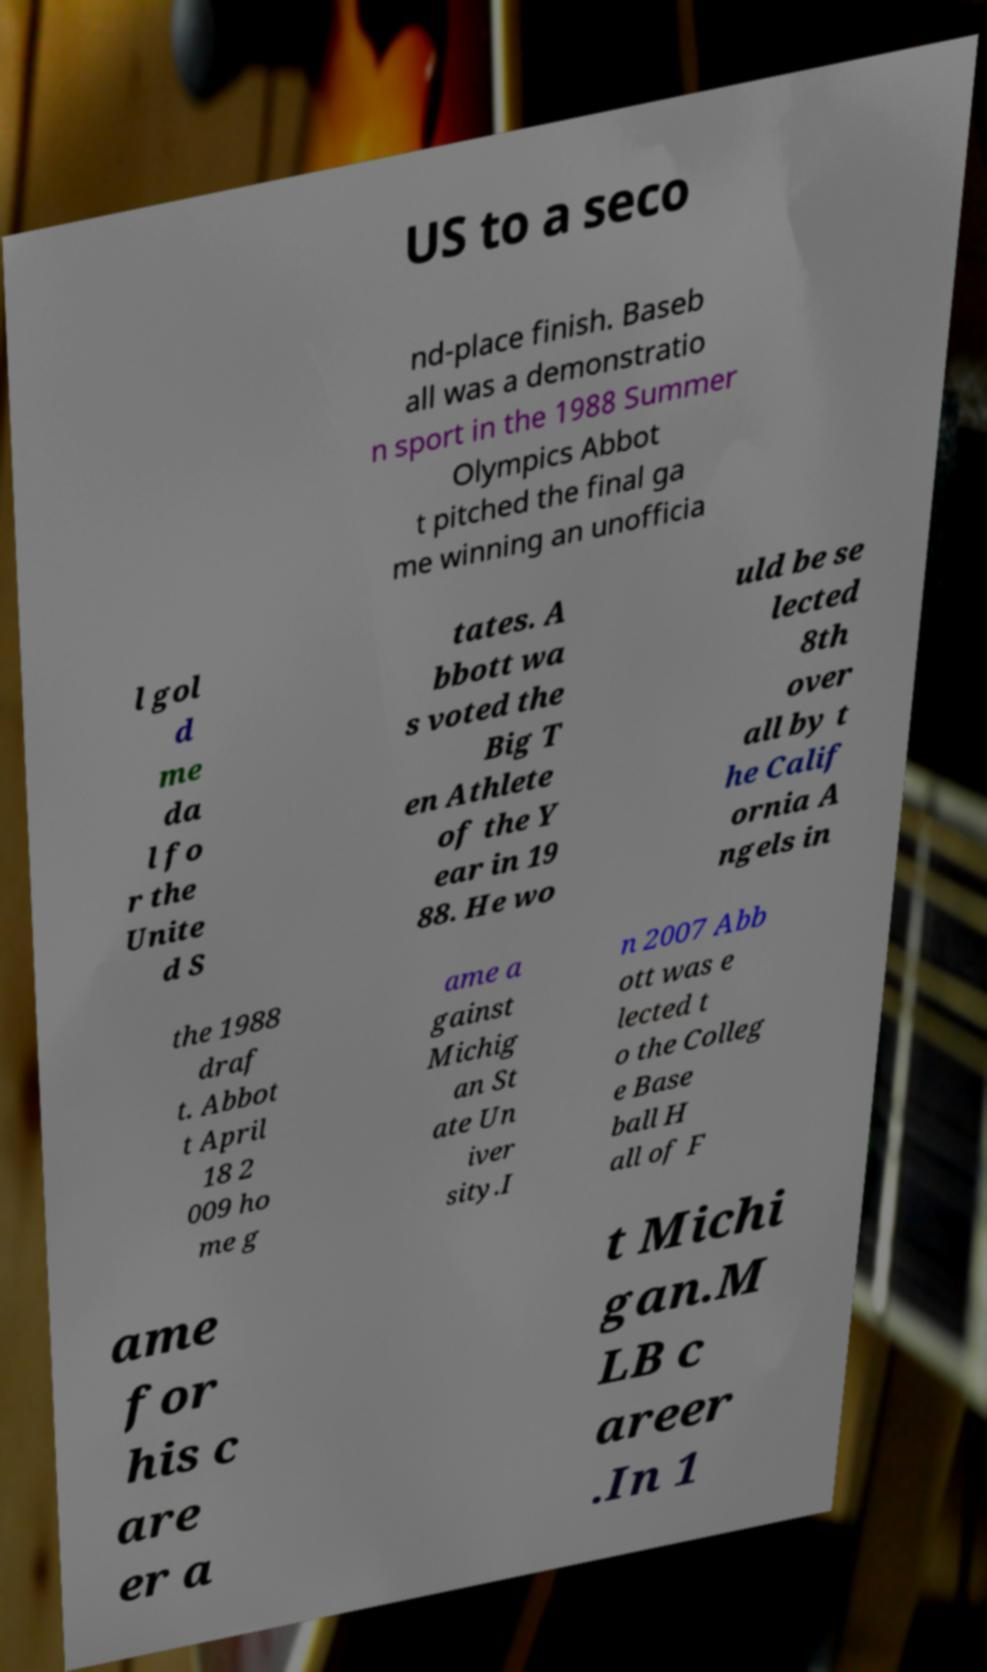What messages or text are displayed in this image? I need them in a readable, typed format. US to a seco nd-place finish. Baseb all was a demonstratio n sport in the 1988 Summer Olympics Abbot t pitched the final ga me winning an unofficia l gol d me da l fo r the Unite d S tates. A bbott wa s voted the Big T en Athlete of the Y ear in 19 88. He wo uld be se lected 8th over all by t he Calif ornia A ngels in the 1988 draf t. Abbot t April 18 2 009 ho me g ame a gainst Michig an St ate Un iver sity.I n 2007 Abb ott was e lected t o the Colleg e Base ball H all of F ame for his c are er a t Michi gan.M LB c areer .In 1 